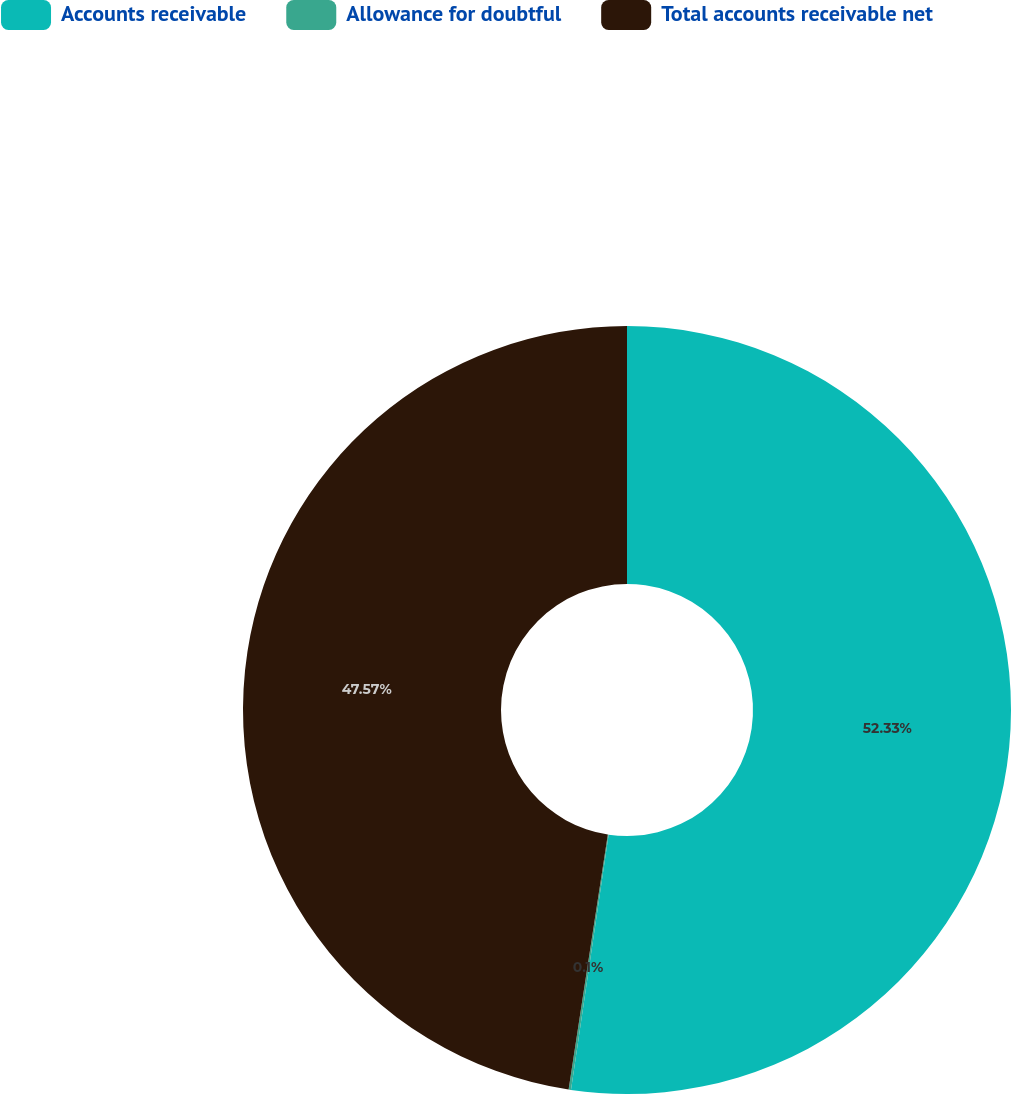<chart> <loc_0><loc_0><loc_500><loc_500><pie_chart><fcel>Accounts receivable<fcel>Allowance for doubtful<fcel>Total accounts receivable net<nl><fcel>52.33%<fcel>0.1%<fcel>47.57%<nl></chart> 